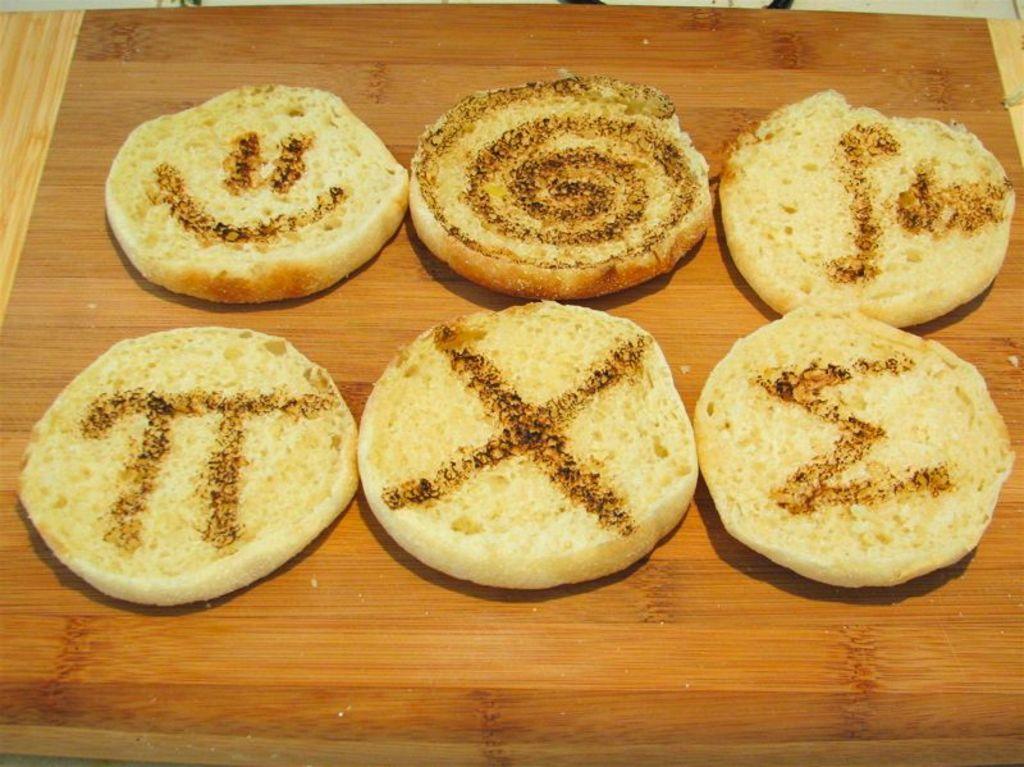How would you summarize this image in a sentence or two? In this image we can see food placed on the surface. 